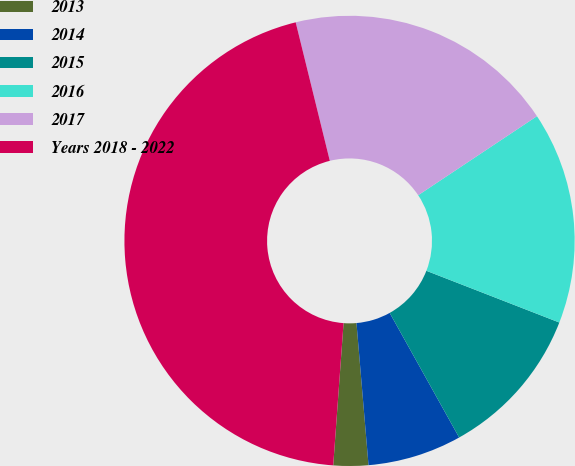Convert chart. <chart><loc_0><loc_0><loc_500><loc_500><pie_chart><fcel>2013<fcel>2014<fcel>2015<fcel>2016<fcel>2017<fcel>Years 2018 - 2022<nl><fcel>2.5%<fcel>6.75%<fcel>11.0%<fcel>15.25%<fcel>19.5%<fcel>45.0%<nl></chart> 